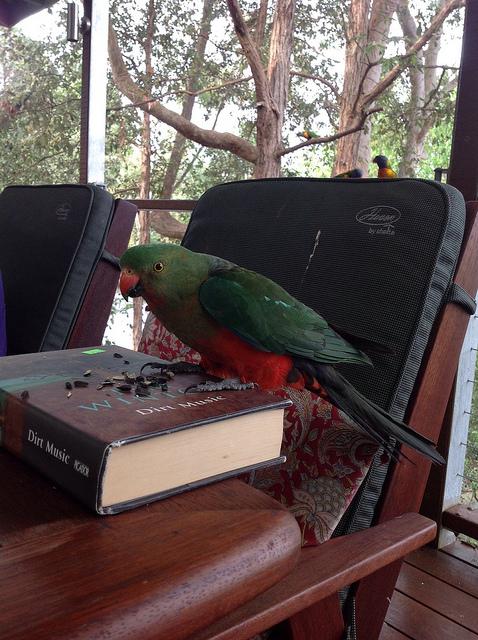What has the parrot put on the book?
Short answer required. Seeds. Is there another bird showing?
Be succinct. Yes. What is the book sitting on?
Give a very brief answer. Table. 